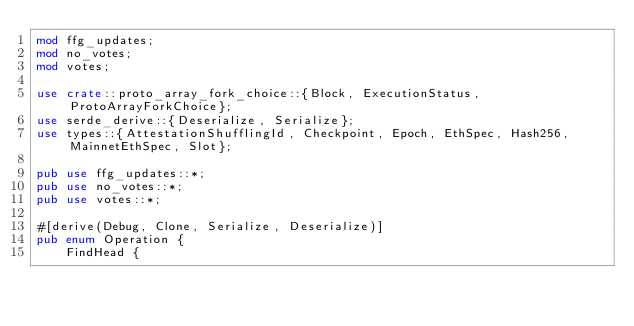Convert code to text. <code><loc_0><loc_0><loc_500><loc_500><_Rust_>mod ffg_updates;
mod no_votes;
mod votes;

use crate::proto_array_fork_choice::{Block, ExecutionStatus, ProtoArrayForkChoice};
use serde_derive::{Deserialize, Serialize};
use types::{AttestationShufflingId, Checkpoint, Epoch, EthSpec, Hash256, MainnetEthSpec, Slot};

pub use ffg_updates::*;
pub use no_votes::*;
pub use votes::*;

#[derive(Debug, Clone, Serialize, Deserialize)]
pub enum Operation {
    FindHead {</code> 